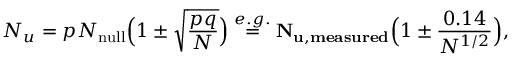Convert formula to latex. <formula><loc_0><loc_0><loc_500><loc_500>N _ { u } = p N _ { n u l l } \left ( 1 \pm \sqrt { \frac { p q } { N } } \right ) \overset { e . g . } { \ = \ } { N _ { u , m e a s u r e d } } \left ( 1 \pm \frac { 0 . 1 4 } { N ^ { 1 / 2 } } \right ) ,</formula> 